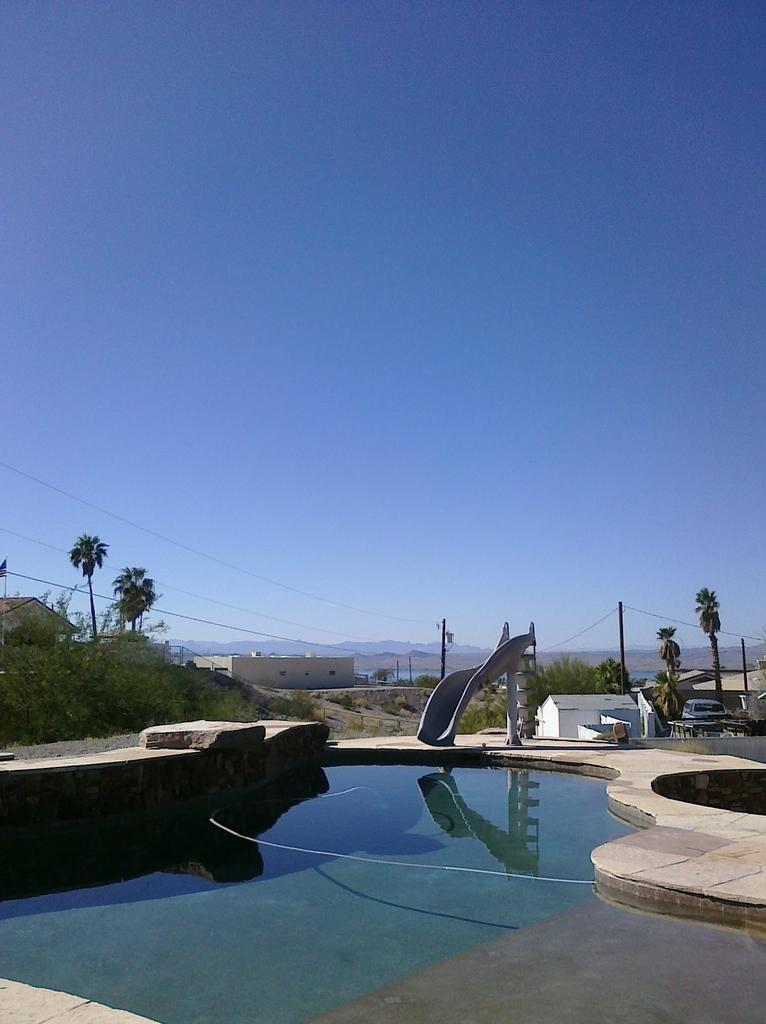What type of water body is present in the image? There is a pond in the image. What structure can be seen on the right side of the image? There appears to be a house on the right side of the image. What type of vegetation is present in the image? There are trees and plants in the image. What can be seen in the background of the image? There are hills and the sky visible in the background of the image. What type of government is depicted in the image? There is no depiction of a government in the image; it features a pond, a house, trees, plants, hills, and the sky. Can you see any spacecraft or astronauts in the image? There are no spacecraft or astronauts present in the image; it is a natural scene with a pond, a house, trees, plants, hills, and the sky. 